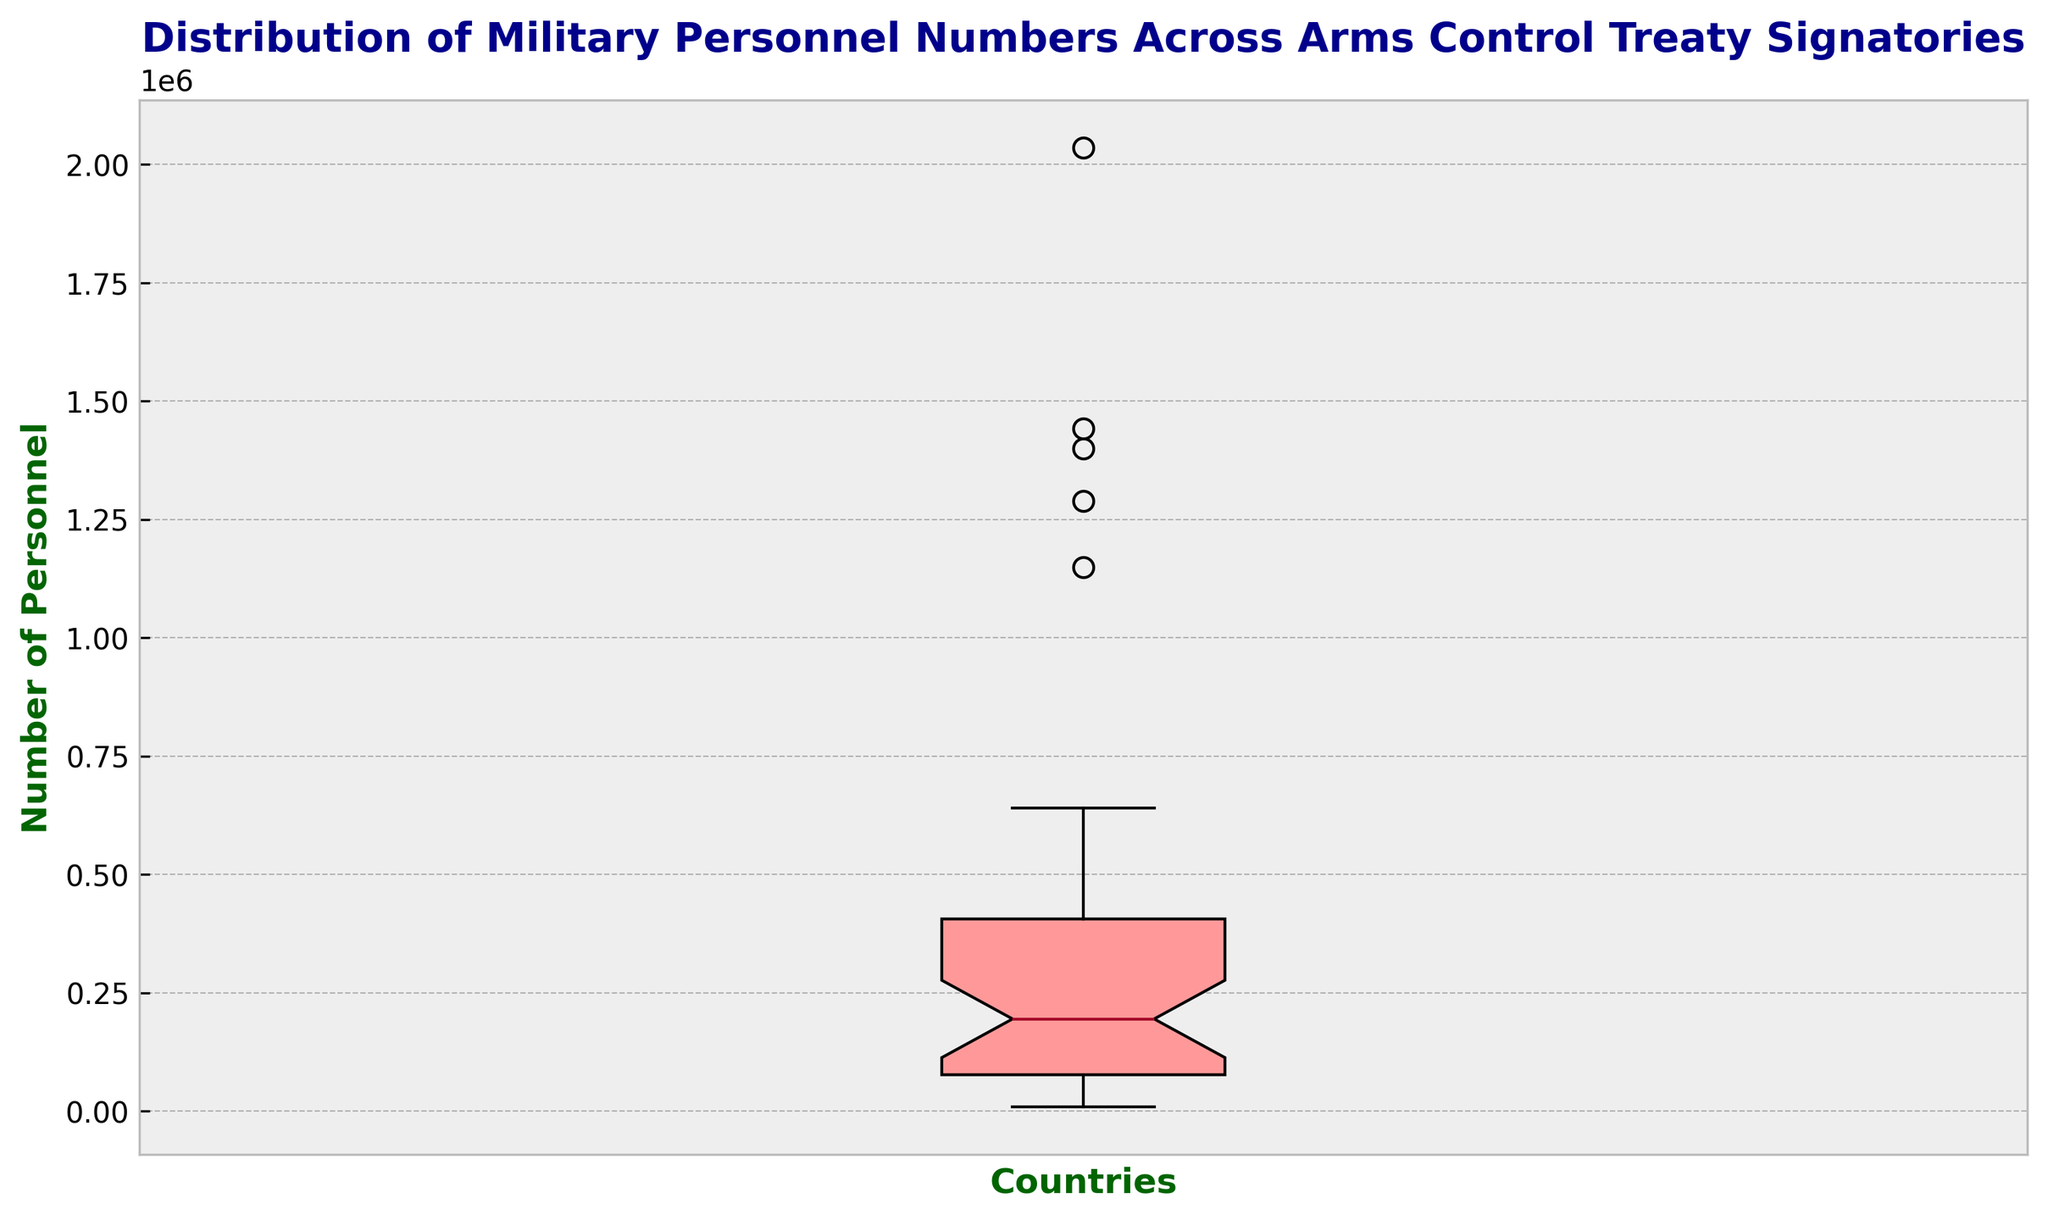what's the median number of military personnel among the listed countries? The median is the middle value of a dataset when arranged in ascending order. From the box plot, the line inside the box represents the median value. You need to locate this line.
Answer: Approximately 247,000 Which country has the most significant number of military personnel? The highest value in a box plot is represented by the top whisker. Identify the top whisker to find the country with the largest number of military personnel.
Answer: China How does the median number of military personnel compare to the average number? First, identify the median number from the box plot. Then calculate the average by summing up all personnel numbers and dividing by the total number of countries. Compare these two values.
Answer: Median is about 247,000; Average is approximately 457,907 Which part of the box plot represents the interquartile range (IQR)? The interquartile range is represented by the "box" itself in a box plot. It spans from the lower quartile (Q1) to the upper quartile (Q3). Identify the limits of the box on the plot.
Answer: The box What is the range of military personnel numbers represented in our dataset? The range can be found by subtracting the smallest value from the largest value. Locate the bottom whisker for the minimum value and the top whisker for the maximum value.
Answer: Approximately 2,025,600 Which countries have military personnel numbers much higher or lower than the others (outliers)? Outliers in a box plot are marked by individual markers outside the whiskers. Identify these points to find the countries with significantly higher or lower military personnel.
Answer: USA, Russia, China, India, North Korea What does the length of the box in the box plot signify? The length of the box signifies the interquartile range (IQR), which measures the spread of the middle 50% of the data. Identify the limits of the box to understand this range.
Answer: Interquartile range of the data Which quartile range includes Mexico's military personnel numbers? First, locate the personnel number for Mexico. Then identify which part of the box plot (Q1 to median, median to Q3, or outside) this number falls into.
Answer: This question is not directly answerable as Mexico is not included in the data Is the distribution of military personnel numbers symmetrical? Examine if the box and whiskers are evenly distributed around the median. A symmetrical distribution would have roughly equal lengths of whiskers and an evenly centered median.
Answer: No, it is right-skewed 